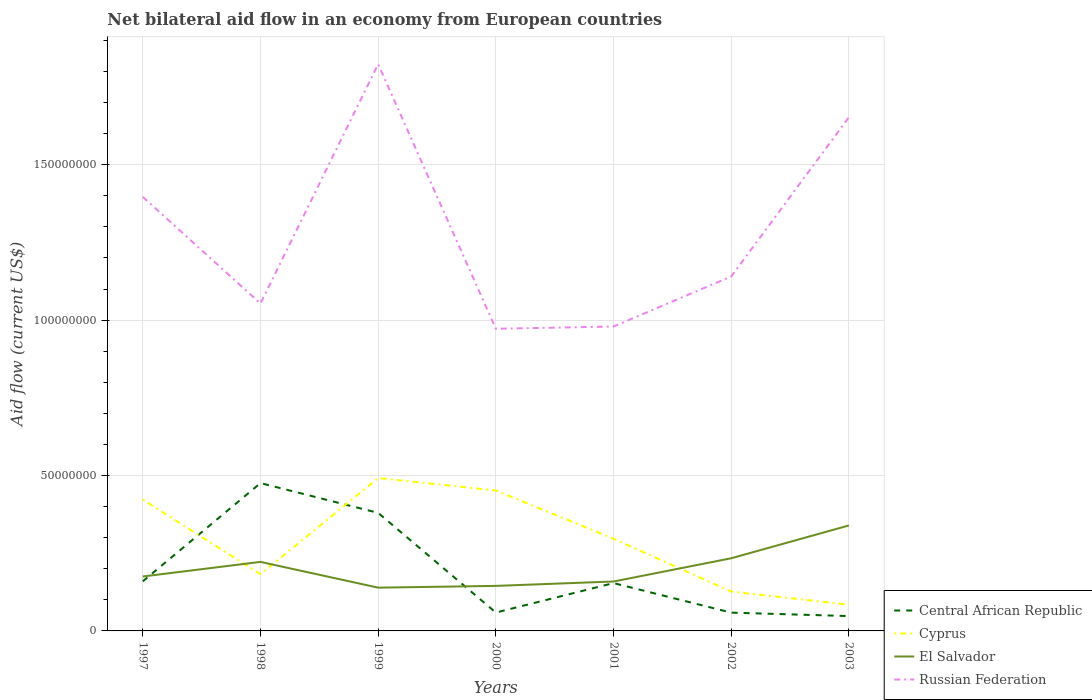Does the line corresponding to El Salvador intersect with the line corresponding to Russian Federation?
Ensure brevity in your answer.  No. Is the number of lines equal to the number of legend labels?
Your answer should be very brief. Yes. Across all years, what is the maximum net bilateral aid flow in Russian Federation?
Make the answer very short. 9.72e+07. What is the total net bilateral aid flow in Cyprus in the graph?
Provide a short and direct response. 2.96e+07. What is the difference between the highest and the second highest net bilateral aid flow in Central African Republic?
Ensure brevity in your answer.  4.28e+07. What is the difference between the highest and the lowest net bilateral aid flow in Russian Federation?
Ensure brevity in your answer.  3. How many years are there in the graph?
Your answer should be compact. 7. What is the difference between two consecutive major ticks on the Y-axis?
Provide a succinct answer. 5.00e+07. Are the values on the major ticks of Y-axis written in scientific E-notation?
Make the answer very short. No. Does the graph contain grids?
Give a very brief answer. Yes. How are the legend labels stacked?
Offer a very short reply. Vertical. What is the title of the graph?
Provide a succinct answer. Net bilateral aid flow in an economy from European countries. What is the Aid flow (current US$) of Central African Republic in 1997?
Give a very brief answer. 1.60e+07. What is the Aid flow (current US$) in Cyprus in 1997?
Provide a short and direct response. 4.23e+07. What is the Aid flow (current US$) in El Salvador in 1997?
Your answer should be very brief. 1.75e+07. What is the Aid flow (current US$) of Russian Federation in 1997?
Your answer should be very brief. 1.40e+08. What is the Aid flow (current US$) in Central African Republic in 1998?
Your answer should be very brief. 4.76e+07. What is the Aid flow (current US$) of Cyprus in 1998?
Offer a terse response. 1.82e+07. What is the Aid flow (current US$) in El Salvador in 1998?
Provide a succinct answer. 2.22e+07. What is the Aid flow (current US$) of Russian Federation in 1998?
Provide a short and direct response. 1.05e+08. What is the Aid flow (current US$) in Central African Republic in 1999?
Make the answer very short. 3.80e+07. What is the Aid flow (current US$) of Cyprus in 1999?
Your response must be concise. 4.92e+07. What is the Aid flow (current US$) in El Salvador in 1999?
Keep it short and to the point. 1.39e+07. What is the Aid flow (current US$) of Russian Federation in 1999?
Make the answer very short. 1.82e+08. What is the Aid flow (current US$) of Central African Republic in 2000?
Keep it short and to the point. 5.91e+06. What is the Aid flow (current US$) of Cyprus in 2000?
Provide a succinct answer. 4.52e+07. What is the Aid flow (current US$) of El Salvador in 2000?
Your answer should be very brief. 1.45e+07. What is the Aid flow (current US$) in Russian Federation in 2000?
Your answer should be very brief. 9.72e+07. What is the Aid flow (current US$) in Central African Republic in 2001?
Keep it short and to the point. 1.54e+07. What is the Aid flow (current US$) in Cyprus in 2001?
Provide a succinct answer. 2.97e+07. What is the Aid flow (current US$) in El Salvador in 2001?
Give a very brief answer. 1.59e+07. What is the Aid flow (current US$) in Russian Federation in 2001?
Provide a short and direct response. 9.80e+07. What is the Aid flow (current US$) of Central African Republic in 2002?
Your answer should be compact. 5.88e+06. What is the Aid flow (current US$) in Cyprus in 2002?
Your response must be concise. 1.27e+07. What is the Aid flow (current US$) of El Salvador in 2002?
Provide a short and direct response. 2.34e+07. What is the Aid flow (current US$) of Russian Federation in 2002?
Provide a short and direct response. 1.14e+08. What is the Aid flow (current US$) of Central African Republic in 2003?
Ensure brevity in your answer.  4.78e+06. What is the Aid flow (current US$) in Cyprus in 2003?
Provide a short and direct response. 8.44e+06. What is the Aid flow (current US$) of El Salvador in 2003?
Keep it short and to the point. 3.39e+07. What is the Aid flow (current US$) in Russian Federation in 2003?
Make the answer very short. 1.65e+08. Across all years, what is the maximum Aid flow (current US$) of Central African Republic?
Provide a succinct answer. 4.76e+07. Across all years, what is the maximum Aid flow (current US$) of Cyprus?
Offer a terse response. 4.92e+07. Across all years, what is the maximum Aid flow (current US$) in El Salvador?
Your answer should be compact. 3.39e+07. Across all years, what is the maximum Aid flow (current US$) of Russian Federation?
Provide a succinct answer. 1.82e+08. Across all years, what is the minimum Aid flow (current US$) in Central African Republic?
Your response must be concise. 4.78e+06. Across all years, what is the minimum Aid flow (current US$) of Cyprus?
Your answer should be very brief. 8.44e+06. Across all years, what is the minimum Aid flow (current US$) of El Salvador?
Give a very brief answer. 1.39e+07. Across all years, what is the minimum Aid flow (current US$) of Russian Federation?
Give a very brief answer. 9.72e+07. What is the total Aid flow (current US$) in Central African Republic in the graph?
Give a very brief answer. 1.33e+08. What is the total Aid flow (current US$) in Cyprus in the graph?
Offer a very short reply. 2.06e+08. What is the total Aid flow (current US$) in El Salvador in the graph?
Your answer should be very brief. 1.41e+08. What is the total Aid flow (current US$) in Russian Federation in the graph?
Your answer should be compact. 9.02e+08. What is the difference between the Aid flow (current US$) of Central African Republic in 1997 and that in 1998?
Give a very brief answer. -3.16e+07. What is the difference between the Aid flow (current US$) of Cyprus in 1997 and that in 1998?
Your response must be concise. 2.40e+07. What is the difference between the Aid flow (current US$) in El Salvador in 1997 and that in 1998?
Your response must be concise. -4.69e+06. What is the difference between the Aid flow (current US$) of Russian Federation in 1997 and that in 1998?
Your answer should be compact. 3.43e+07. What is the difference between the Aid flow (current US$) in Central African Republic in 1997 and that in 1999?
Provide a succinct answer. -2.20e+07. What is the difference between the Aid flow (current US$) in Cyprus in 1997 and that in 1999?
Make the answer very short. -6.93e+06. What is the difference between the Aid flow (current US$) of El Salvador in 1997 and that in 1999?
Make the answer very short. 3.60e+06. What is the difference between the Aid flow (current US$) in Russian Federation in 1997 and that in 1999?
Your answer should be compact. -4.27e+07. What is the difference between the Aid flow (current US$) of Central African Republic in 1997 and that in 2000?
Offer a terse response. 1.00e+07. What is the difference between the Aid flow (current US$) in Cyprus in 1997 and that in 2000?
Your response must be concise. -2.93e+06. What is the difference between the Aid flow (current US$) in El Salvador in 1997 and that in 2000?
Offer a terse response. 3.03e+06. What is the difference between the Aid flow (current US$) of Russian Federation in 1997 and that in 2000?
Your response must be concise. 4.24e+07. What is the difference between the Aid flow (current US$) in Central African Republic in 1997 and that in 2001?
Your answer should be compact. 5.70e+05. What is the difference between the Aid flow (current US$) in Cyprus in 1997 and that in 2001?
Give a very brief answer. 1.26e+07. What is the difference between the Aid flow (current US$) in El Salvador in 1997 and that in 2001?
Make the answer very short. 1.62e+06. What is the difference between the Aid flow (current US$) in Russian Federation in 1997 and that in 2001?
Ensure brevity in your answer.  4.17e+07. What is the difference between the Aid flow (current US$) in Central African Republic in 1997 and that in 2002?
Provide a succinct answer. 1.01e+07. What is the difference between the Aid flow (current US$) of Cyprus in 1997 and that in 2002?
Ensure brevity in your answer.  2.96e+07. What is the difference between the Aid flow (current US$) of El Salvador in 1997 and that in 2002?
Your answer should be compact. -5.86e+06. What is the difference between the Aid flow (current US$) of Russian Federation in 1997 and that in 2002?
Provide a short and direct response. 2.56e+07. What is the difference between the Aid flow (current US$) of Central African Republic in 1997 and that in 2003?
Offer a terse response. 1.12e+07. What is the difference between the Aid flow (current US$) in Cyprus in 1997 and that in 2003?
Ensure brevity in your answer.  3.38e+07. What is the difference between the Aid flow (current US$) of El Salvador in 1997 and that in 2003?
Ensure brevity in your answer.  -1.64e+07. What is the difference between the Aid flow (current US$) of Russian Federation in 1997 and that in 2003?
Give a very brief answer. -2.56e+07. What is the difference between the Aid flow (current US$) in Central African Republic in 1998 and that in 1999?
Provide a short and direct response. 9.59e+06. What is the difference between the Aid flow (current US$) of Cyprus in 1998 and that in 1999?
Your answer should be compact. -3.10e+07. What is the difference between the Aid flow (current US$) in El Salvador in 1998 and that in 1999?
Your answer should be compact. 8.29e+06. What is the difference between the Aid flow (current US$) in Russian Federation in 1998 and that in 1999?
Keep it short and to the point. -7.70e+07. What is the difference between the Aid flow (current US$) in Central African Republic in 1998 and that in 2000?
Provide a short and direct response. 4.17e+07. What is the difference between the Aid flow (current US$) of Cyprus in 1998 and that in 2000?
Your answer should be compact. -2.70e+07. What is the difference between the Aid flow (current US$) of El Salvador in 1998 and that in 2000?
Your answer should be very brief. 7.72e+06. What is the difference between the Aid flow (current US$) in Russian Federation in 1998 and that in 2000?
Your response must be concise. 8.12e+06. What is the difference between the Aid flow (current US$) in Central African Republic in 1998 and that in 2001?
Give a very brief answer. 3.22e+07. What is the difference between the Aid flow (current US$) in Cyprus in 1998 and that in 2001?
Your answer should be very brief. -1.14e+07. What is the difference between the Aid flow (current US$) of El Salvador in 1998 and that in 2001?
Your response must be concise. 6.31e+06. What is the difference between the Aid flow (current US$) of Russian Federation in 1998 and that in 2001?
Your answer should be compact. 7.39e+06. What is the difference between the Aid flow (current US$) in Central African Republic in 1998 and that in 2002?
Offer a very short reply. 4.17e+07. What is the difference between the Aid flow (current US$) of Cyprus in 1998 and that in 2002?
Keep it short and to the point. 5.57e+06. What is the difference between the Aid flow (current US$) in El Salvador in 1998 and that in 2002?
Make the answer very short. -1.17e+06. What is the difference between the Aid flow (current US$) in Russian Federation in 1998 and that in 2002?
Your response must be concise. -8.71e+06. What is the difference between the Aid flow (current US$) of Central African Republic in 1998 and that in 2003?
Your response must be concise. 4.28e+07. What is the difference between the Aid flow (current US$) of Cyprus in 1998 and that in 2003?
Offer a terse response. 9.79e+06. What is the difference between the Aid flow (current US$) of El Salvador in 1998 and that in 2003?
Offer a terse response. -1.17e+07. What is the difference between the Aid flow (current US$) in Russian Federation in 1998 and that in 2003?
Keep it short and to the point. -5.99e+07. What is the difference between the Aid flow (current US$) in Central African Republic in 1999 and that in 2000?
Make the answer very short. 3.21e+07. What is the difference between the Aid flow (current US$) of El Salvador in 1999 and that in 2000?
Give a very brief answer. -5.70e+05. What is the difference between the Aid flow (current US$) of Russian Federation in 1999 and that in 2000?
Offer a terse response. 8.51e+07. What is the difference between the Aid flow (current US$) in Central African Republic in 1999 and that in 2001?
Give a very brief answer. 2.26e+07. What is the difference between the Aid flow (current US$) of Cyprus in 1999 and that in 2001?
Your response must be concise. 1.95e+07. What is the difference between the Aid flow (current US$) of El Salvador in 1999 and that in 2001?
Keep it short and to the point. -1.98e+06. What is the difference between the Aid flow (current US$) in Russian Federation in 1999 and that in 2001?
Your response must be concise. 8.44e+07. What is the difference between the Aid flow (current US$) of Central African Republic in 1999 and that in 2002?
Make the answer very short. 3.21e+07. What is the difference between the Aid flow (current US$) in Cyprus in 1999 and that in 2002?
Provide a succinct answer. 3.65e+07. What is the difference between the Aid flow (current US$) of El Salvador in 1999 and that in 2002?
Keep it short and to the point. -9.46e+06. What is the difference between the Aid flow (current US$) of Russian Federation in 1999 and that in 2002?
Make the answer very short. 6.83e+07. What is the difference between the Aid flow (current US$) in Central African Republic in 1999 and that in 2003?
Keep it short and to the point. 3.32e+07. What is the difference between the Aid flow (current US$) of Cyprus in 1999 and that in 2003?
Make the answer very short. 4.08e+07. What is the difference between the Aid flow (current US$) in El Salvador in 1999 and that in 2003?
Your answer should be very brief. -2.00e+07. What is the difference between the Aid flow (current US$) in Russian Federation in 1999 and that in 2003?
Your answer should be compact. 1.71e+07. What is the difference between the Aid flow (current US$) in Central African Republic in 2000 and that in 2001?
Your answer should be very brief. -9.48e+06. What is the difference between the Aid flow (current US$) in Cyprus in 2000 and that in 2001?
Give a very brief answer. 1.55e+07. What is the difference between the Aid flow (current US$) of El Salvador in 2000 and that in 2001?
Make the answer very short. -1.41e+06. What is the difference between the Aid flow (current US$) in Russian Federation in 2000 and that in 2001?
Offer a very short reply. -7.30e+05. What is the difference between the Aid flow (current US$) in Cyprus in 2000 and that in 2002?
Offer a very short reply. 3.25e+07. What is the difference between the Aid flow (current US$) of El Salvador in 2000 and that in 2002?
Your response must be concise. -8.89e+06. What is the difference between the Aid flow (current US$) of Russian Federation in 2000 and that in 2002?
Your response must be concise. -1.68e+07. What is the difference between the Aid flow (current US$) in Central African Republic in 2000 and that in 2003?
Offer a very short reply. 1.13e+06. What is the difference between the Aid flow (current US$) of Cyprus in 2000 and that in 2003?
Make the answer very short. 3.68e+07. What is the difference between the Aid flow (current US$) in El Salvador in 2000 and that in 2003?
Offer a very short reply. -1.94e+07. What is the difference between the Aid flow (current US$) of Russian Federation in 2000 and that in 2003?
Keep it short and to the point. -6.81e+07. What is the difference between the Aid flow (current US$) of Central African Republic in 2001 and that in 2002?
Keep it short and to the point. 9.51e+06. What is the difference between the Aid flow (current US$) of Cyprus in 2001 and that in 2002?
Your response must be concise. 1.70e+07. What is the difference between the Aid flow (current US$) of El Salvador in 2001 and that in 2002?
Provide a succinct answer. -7.48e+06. What is the difference between the Aid flow (current US$) of Russian Federation in 2001 and that in 2002?
Provide a short and direct response. -1.61e+07. What is the difference between the Aid flow (current US$) in Central African Republic in 2001 and that in 2003?
Your response must be concise. 1.06e+07. What is the difference between the Aid flow (current US$) in Cyprus in 2001 and that in 2003?
Make the answer very short. 2.12e+07. What is the difference between the Aid flow (current US$) in El Salvador in 2001 and that in 2003?
Make the answer very short. -1.80e+07. What is the difference between the Aid flow (current US$) in Russian Federation in 2001 and that in 2003?
Ensure brevity in your answer.  -6.73e+07. What is the difference between the Aid flow (current US$) in Central African Republic in 2002 and that in 2003?
Your response must be concise. 1.10e+06. What is the difference between the Aid flow (current US$) of Cyprus in 2002 and that in 2003?
Offer a terse response. 4.22e+06. What is the difference between the Aid flow (current US$) of El Salvador in 2002 and that in 2003?
Your response must be concise. -1.06e+07. What is the difference between the Aid flow (current US$) in Russian Federation in 2002 and that in 2003?
Provide a succinct answer. -5.12e+07. What is the difference between the Aid flow (current US$) in Central African Republic in 1997 and the Aid flow (current US$) in Cyprus in 1998?
Your answer should be compact. -2.27e+06. What is the difference between the Aid flow (current US$) of Central African Republic in 1997 and the Aid flow (current US$) of El Salvador in 1998?
Your answer should be very brief. -6.25e+06. What is the difference between the Aid flow (current US$) in Central African Republic in 1997 and the Aid flow (current US$) in Russian Federation in 1998?
Provide a short and direct response. -8.94e+07. What is the difference between the Aid flow (current US$) in Cyprus in 1997 and the Aid flow (current US$) in El Salvador in 1998?
Your answer should be compact. 2.00e+07. What is the difference between the Aid flow (current US$) in Cyprus in 1997 and the Aid flow (current US$) in Russian Federation in 1998?
Make the answer very short. -6.31e+07. What is the difference between the Aid flow (current US$) in El Salvador in 1997 and the Aid flow (current US$) in Russian Federation in 1998?
Your answer should be very brief. -8.78e+07. What is the difference between the Aid flow (current US$) in Central African Republic in 1997 and the Aid flow (current US$) in Cyprus in 1999?
Make the answer very short. -3.32e+07. What is the difference between the Aid flow (current US$) of Central African Republic in 1997 and the Aid flow (current US$) of El Salvador in 1999?
Offer a very short reply. 2.04e+06. What is the difference between the Aid flow (current US$) in Central African Republic in 1997 and the Aid flow (current US$) in Russian Federation in 1999?
Your answer should be compact. -1.66e+08. What is the difference between the Aid flow (current US$) of Cyprus in 1997 and the Aid flow (current US$) of El Salvador in 1999?
Your answer should be very brief. 2.83e+07. What is the difference between the Aid flow (current US$) of Cyprus in 1997 and the Aid flow (current US$) of Russian Federation in 1999?
Offer a very short reply. -1.40e+08. What is the difference between the Aid flow (current US$) in El Salvador in 1997 and the Aid flow (current US$) in Russian Federation in 1999?
Provide a short and direct response. -1.65e+08. What is the difference between the Aid flow (current US$) in Central African Republic in 1997 and the Aid flow (current US$) in Cyprus in 2000?
Offer a very short reply. -2.92e+07. What is the difference between the Aid flow (current US$) of Central African Republic in 1997 and the Aid flow (current US$) of El Salvador in 2000?
Provide a short and direct response. 1.47e+06. What is the difference between the Aid flow (current US$) of Central African Republic in 1997 and the Aid flow (current US$) of Russian Federation in 2000?
Make the answer very short. -8.13e+07. What is the difference between the Aid flow (current US$) of Cyprus in 1997 and the Aid flow (current US$) of El Salvador in 2000?
Your response must be concise. 2.78e+07. What is the difference between the Aid flow (current US$) in Cyprus in 1997 and the Aid flow (current US$) in Russian Federation in 2000?
Ensure brevity in your answer.  -5.50e+07. What is the difference between the Aid flow (current US$) of El Salvador in 1997 and the Aid flow (current US$) of Russian Federation in 2000?
Give a very brief answer. -7.97e+07. What is the difference between the Aid flow (current US$) in Central African Republic in 1997 and the Aid flow (current US$) in Cyprus in 2001?
Ensure brevity in your answer.  -1.37e+07. What is the difference between the Aid flow (current US$) in Central African Republic in 1997 and the Aid flow (current US$) in El Salvador in 2001?
Ensure brevity in your answer.  6.00e+04. What is the difference between the Aid flow (current US$) of Central African Republic in 1997 and the Aid flow (current US$) of Russian Federation in 2001?
Make the answer very short. -8.20e+07. What is the difference between the Aid flow (current US$) in Cyprus in 1997 and the Aid flow (current US$) in El Salvador in 2001?
Give a very brief answer. 2.64e+07. What is the difference between the Aid flow (current US$) of Cyprus in 1997 and the Aid flow (current US$) of Russian Federation in 2001?
Provide a succinct answer. -5.57e+07. What is the difference between the Aid flow (current US$) in El Salvador in 1997 and the Aid flow (current US$) in Russian Federation in 2001?
Your answer should be compact. -8.04e+07. What is the difference between the Aid flow (current US$) of Central African Republic in 1997 and the Aid flow (current US$) of Cyprus in 2002?
Your answer should be compact. 3.30e+06. What is the difference between the Aid flow (current US$) of Central African Republic in 1997 and the Aid flow (current US$) of El Salvador in 2002?
Your answer should be compact. -7.42e+06. What is the difference between the Aid flow (current US$) in Central African Republic in 1997 and the Aid flow (current US$) in Russian Federation in 2002?
Offer a very short reply. -9.81e+07. What is the difference between the Aid flow (current US$) in Cyprus in 1997 and the Aid flow (current US$) in El Salvador in 2002?
Provide a succinct answer. 1.89e+07. What is the difference between the Aid flow (current US$) of Cyprus in 1997 and the Aid flow (current US$) of Russian Federation in 2002?
Provide a short and direct response. -7.18e+07. What is the difference between the Aid flow (current US$) in El Salvador in 1997 and the Aid flow (current US$) in Russian Federation in 2002?
Make the answer very short. -9.65e+07. What is the difference between the Aid flow (current US$) of Central African Republic in 1997 and the Aid flow (current US$) of Cyprus in 2003?
Keep it short and to the point. 7.52e+06. What is the difference between the Aid flow (current US$) in Central African Republic in 1997 and the Aid flow (current US$) in El Salvador in 2003?
Make the answer very short. -1.80e+07. What is the difference between the Aid flow (current US$) in Central African Republic in 1997 and the Aid flow (current US$) in Russian Federation in 2003?
Offer a terse response. -1.49e+08. What is the difference between the Aid flow (current US$) in Cyprus in 1997 and the Aid flow (current US$) in El Salvador in 2003?
Provide a short and direct response. 8.32e+06. What is the difference between the Aid flow (current US$) in Cyprus in 1997 and the Aid flow (current US$) in Russian Federation in 2003?
Provide a short and direct response. -1.23e+08. What is the difference between the Aid flow (current US$) of El Salvador in 1997 and the Aid flow (current US$) of Russian Federation in 2003?
Give a very brief answer. -1.48e+08. What is the difference between the Aid flow (current US$) of Central African Republic in 1998 and the Aid flow (current US$) of Cyprus in 1999?
Ensure brevity in your answer.  -1.62e+06. What is the difference between the Aid flow (current US$) in Central African Republic in 1998 and the Aid flow (current US$) in El Salvador in 1999?
Offer a terse response. 3.36e+07. What is the difference between the Aid flow (current US$) in Central African Republic in 1998 and the Aid flow (current US$) in Russian Federation in 1999?
Provide a succinct answer. -1.35e+08. What is the difference between the Aid flow (current US$) of Cyprus in 1998 and the Aid flow (current US$) of El Salvador in 1999?
Your answer should be compact. 4.31e+06. What is the difference between the Aid flow (current US$) of Cyprus in 1998 and the Aid flow (current US$) of Russian Federation in 1999?
Your response must be concise. -1.64e+08. What is the difference between the Aid flow (current US$) in El Salvador in 1998 and the Aid flow (current US$) in Russian Federation in 1999?
Your response must be concise. -1.60e+08. What is the difference between the Aid flow (current US$) in Central African Republic in 1998 and the Aid flow (current US$) in Cyprus in 2000?
Offer a terse response. 2.38e+06. What is the difference between the Aid flow (current US$) of Central African Republic in 1998 and the Aid flow (current US$) of El Salvador in 2000?
Ensure brevity in your answer.  3.31e+07. What is the difference between the Aid flow (current US$) of Central African Republic in 1998 and the Aid flow (current US$) of Russian Federation in 2000?
Your response must be concise. -4.96e+07. What is the difference between the Aid flow (current US$) of Cyprus in 1998 and the Aid flow (current US$) of El Salvador in 2000?
Your answer should be very brief. 3.74e+06. What is the difference between the Aid flow (current US$) of Cyprus in 1998 and the Aid flow (current US$) of Russian Federation in 2000?
Provide a succinct answer. -7.90e+07. What is the difference between the Aid flow (current US$) of El Salvador in 1998 and the Aid flow (current US$) of Russian Federation in 2000?
Provide a succinct answer. -7.50e+07. What is the difference between the Aid flow (current US$) in Central African Republic in 1998 and the Aid flow (current US$) in Cyprus in 2001?
Ensure brevity in your answer.  1.79e+07. What is the difference between the Aid flow (current US$) in Central African Republic in 1998 and the Aid flow (current US$) in El Salvador in 2001?
Your answer should be compact. 3.17e+07. What is the difference between the Aid flow (current US$) in Central African Republic in 1998 and the Aid flow (current US$) in Russian Federation in 2001?
Make the answer very short. -5.04e+07. What is the difference between the Aid flow (current US$) in Cyprus in 1998 and the Aid flow (current US$) in El Salvador in 2001?
Ensure brevity in your answer.  2.33e+06. What is the difference between the Aid flow (current US$) in Cyprus in 1998 and the Aid flow (current US$) in Russian Federation in 2001?
Your response must be concise. -7.97e+07. What is the difference between the Aid flow (current US$) in El Salvador in 1998 and the Aid flow (current US$) in Russian Federation in 2001?
Your response must be concise. -7.57e+07. What is the difference between the Aid flow (current US$) of Central African Republic in 1998 and the Aid flow (current US$) of Cyprus in 2002?
Your response must be concise. 3.49e+07. What is the difference between the Aid flow (current US$) of Central African Republic in 1998 and the Aid flow (current US$) of El Salvador in 2002?
Keep it short and to the point. 2.42e+07. What is the difference between the Aid flow (current US$) in Central African Republic in 1998 and the Aid flow (current US$) in Russian Federation in 2002?
Keep it short and to the point. -6.65e+07. What is the difference between the Aid flow (current US$) in Cyprus in 1998 and the Aid flow (current US$) in El Salvador in 2002?
Give a very brief answer. -5.15e+06. What is the difference between the Aid flow (current US$) in Cyprus in 1998 and the Aid flow (current US$) in Russian Federation in 2002?
Provide a short and direct response. -9.58e+07. What is the difference between the Aid flow (current US$) of El Salvador in 1998 and the Aid flow (current US$) of Russian Federation in 2002?
Provide a short and direct response. -9.18e+07. What is the difference between the Aid flow (current US$) in Central African Republic in 1998 and the Aid flow (current US$) in Cyprus in 2003?
Your response must be concise. 3.91e+07. What is the difference between the Aid flow (current US$) in Central African Republic in 1998 and the Aid flow (current US$) in El Salvador in 2003?
Ensure brevity in your answer.  1.36e+07. What is the difference between the Aid flow (current US$) in Central African Republic in 1998 and the Aid flow (current US$) in Russian Federation in 2003?
Give a very brief answer. -1.18e+08. What is the difference between the Aid flow (current US$) of Cyprus in 1998 and the Aid flow (current US$) of El Salvador in 2003?
Offer a very short reply. -1.57e+07. What is the difference between the Aid flow (current US$) of Cyprus in 1998 and the Aid flow (current US$) of Russian Federation in 2003?
Your answer should be compact. -1.47e+08. What is the difference between the Aid flow (current US$) in El Salvador in 1998 and the Aid flow (current US$) in Russian Federation in 2003?
Your answer should be very brief. -1.43e+08. What is the difference between the Aid flow (current US$) in Central African Republic in 1999 and the Aid flow (current US$) in Cyprus in 2000?
Make the answer very short. -7.21e+06. What is the difference between the Aid flow (current US$) of Central African Republic in 1999 and the Aid flow (current US$) of El Salvador in 2000?
Provide a succinct answer. 2.35e+07. What is the difference between the Aid flow (current US$) in Central African Republic in 1999 and the Aid flow (current US$) in Russian Federation in 2000?
Ensure brevity in your answer.  -5.92e+07. What is the difference between the Aid flow (current US$) of Cyprus in 1999 and the Aid flow (current US$) of El Salvador in 2000?
Offer a very short reply. 3.47e+07. What is the difference between the Aid flow (current US$) of Cyprus in 1999 and the Aid flow (current US$) of Russian Federation in 2000?
Provide a succinct answer. -4.80e+07. What is the difference between the Aid flow (current US$) of El Salvador in 1999 and the Aid flow (current US$) of Russian Federation in 2000?
Provide a succinct answer. -8.33e+07. What is the difference between the Aid flow (current US$) of Central African Republic in 1999 and the Aid flow (current US$) of Cyprus in 2001?
Keep it short and to the point. 8.32e+06. What is the difference between the Aid flow (current US$) in Central African Republic in 1999 and the Aid flow (current US$) in El Salvador in 2001?
Provide a succinct answer. 2.21e+07. What is the difference between the Aid flow (current US$) in Central African Republic in 1999 and the Aid flow (current US$) in Russian Federation in 2001?
Provide a succinct answer. -6.00e+07. What is the difference between the Aid flow (current US$) in Cyprus in 1999 and the Aid flow (current US$) in El Salvador in 2001?
Your answer should be very brief. 3.33e+07. What is the difference between the Aid flow (current US$) in Cyprus in 1999 and the Aid flow (current US$) in Russian Federation in 2001?
Your response must be concise. -4.88e+07. What is the difference between the Aid flow (current US$) in El Salvador in 1999 and the Aid flow (current US$) in Russian Federation in 2001?
Your answer should be compact. -8.40e+07. What is the difference between the Aid flow (current US$) in Central African Republic in 1999 and the Aid flow (current US$) in Cyprus in 2002?
Ensure brevity in your answer.  2.53e+07. What is the difference between the Aid flow (current US$) in Central African Republic in 1999 and the Aid flow (current US$) in El Salvador in 2002?
Keep it short and to the point. 1.46e+07. What is the difference between the Aid flow (current US$) in Central African Republic in 1999 and the Aid flow (current US$) in Russian Federation in 2002?
Provide a succinct answer. -7.61e+07. What is the difference between the Aid flow (current US$) in Cyprus in 1999 and the Aid flow (current US$) in El Salvador in 2002?
Your answer should be compact. 2.58e+07. What is the difference between the Aid flow (current US$) in Cyprus in 1999 and the Aid flow (current US$) in Russian Federation in 2002?
Ensure brevity in your answer.  -6.49e+07. What is the difference between the Aid flow (current US$) in El Salvador in 1999 and the Aid flow (current US$) in Russian Federation in 2002?
Provide a short and direct response. -1.00e+08. What is the difference between the Aid flow (current US$) of Central African Republic in 1999 and the Aid flow (current US$) of Cyprus in 2003?
Keep it short and to the point. 2.95e+07. What is the difference between the Aid flow (current US$) in Central African Republic in 1999 and the Aid flow (current US$) in El Salvador in 2003?
Offer a terse response. 4.04e+06. What is the difference between the Aid flow (current US$) of Central African Republic in 1999 and the Aid flow (current US$) of Russian Federation in 2003?
Offer a very short reply. -1.27e+08. What is the difference between the Aid flow (current US$) in Cyprus in 1999 and the Aid flow (current US$) in El Salvador in 2003?
Your response must be concise. 1.52e+07. What is the difference between the Aid flow (current US$) in Cyprus in 1999 and the Aid flow (current US$) in Russian Federation in 2003?
Provide a short and direct response. -1.16e+08. What is the difference between the Aid flow (current US$) of El Salvador in 1999 and the Aid flow (current US$) of Russian Federation in 2003?
Ensure brevity in your answer.  -1.51e+08. What is the difference between the Aid flow (current US$) in Central African Republic in 2000 and the Aid flow (current US$) in Cyprus in 2001?
Provide a succinct answer. -2.38e+07. What is the difference between the Aid flow (current US$) of Central African Republic in 2000 and the Aid flow (current US$) of El Salvador in 2001?
Give a very brief answer. -9.99e+06. What is the difference between the Aid flow (current US$) of Central African Republic in 2000 and the Aid flow (current US$) of Russian Federation in 2001?
Provide a succinct answer. -9.20e+07. What is the difference between the Aid flow (current US$) in Cyprus in 2000 and the Aid flow (current US$) in El Salvador in 2001?
Provide a succinct answer. 2.93e+07. What is the difference between the Aid flow (current US$) in Cyprus in 2000 and the Aid flow (current US$) in Russian Federation in 2001?
Your answer should be compact. -5.28e+07. What is the difference between the Aid flow (current US$) of El Salvador in 2000 and the Aid flow (current US$) of Russian Federation in 2001?
Ensure brevity in your answer.  -8.35e+07. What is the difference between the Aid flow (current US$) in Central African Republic in 2000 and the Aid flow (current US$) in Cyprus in 2002?
Keep it short and to the point. -6.75e+06. What is the difference between the Aid flow (current US$) in Central African Republic in 2000 and the Aid flow (current US$) in El Salvador in 2002?
Ensure brevity in your answer.  -1.75e+07. What is the difference between the Aid flow (current US$) in Central African Republic in 2000 and the Aid flow (current US$) in Russian Federation in 2002?
Your answer should be compact. -1.08e+08. What is the difference between the Aid flow (current US$) in Cyprus in 2000 and the Aid flow (current US$) in El Salvador in 2002?
Your answer should be compact. 2.18e+07. What is the difference between the Aid flow (current US$) of Cyprus in 2000 and the Aid flow (current US$) of Russian Federation in 2002?
Your response must be concise. -6.89e+07. What is the difference between the Aid flow (current US$) of El Salvador in 2000 and the Aid flow (current US$) of Russian Federation in 2002?
Offer a very short reply. -9.96e+07. What is the difference between the Aid flow (current US$) in Central African Republic in 2000 and the Aid flow (current US$) in Cyprus in 2003?
Make the answer very short. -2.53e+06. What is the difference between the Aid flow (current US$) of Central African Republic in 2000 and the Aid flow (current US$) of El Salvador in 2003?
Give a very brief answer. -2.80e+07. What is the difference between the Aid flow (current US$) of Central African Republic in 2000 and the Aid flow (current US$) of Russian Federation in 2003?
Offer a terse response. -1.59e+08. What is the difference between the Aid flow (current US$) of Cyprus in 2000 and the Aid flow (current US$) of El Salvador in 2003?
Your response must be concise. 1.12e+07. What is the difference between the Aid flow (current US$) in Cyprus in 2000 and the Aid flow (current US$) in Russian Federation in 2003?
Your response must be concise. -1.20e+08. What is the difference between the Aid flow (current US$) in El Salvador in 2000 and the Aid flow (current US$) in Russian Federation in 2003?
Your answer should be very brief. -1.51e+08. What is the difference between the Aid flow (current US$) of Central African Republic in 2001 and the Aid flow (current US$) of Cyprus in 2002?
Keep it short and to the point. 2.73e+06. What is the difference between the Aid flow (current US$) in Central African Republic in 2001 and the Aid flow (current US$) in El Salvador in 2002?
Provide a short and direct response. -7.99e+06. What is the difference between the Aid flow (current US$) of Central African Republic in 2001 and the Aid flow (current US$) of Russian Federation in 2002?
Provide a succinct answer. -9.87e+07. What is the difference between the Aid flow (current US$) of Cyprus in 2001 and the Aid flow (current US$) of El Salvador in 2002?
Your answer should be very brief. 6.28e+06. What is the difference between the Aid flow (current US$) of Cyprus in 2001 and the Aid flow (current US$) of Russian Federation in 2002?
Ensure brevity in your answer.  -8.44e+07. What is the difference between the Aid flow (current US$) of El Salvador in 2001 and the Aid flow (current US$) of Russian Federation in 2002?
Give a very brief answer. -9.82e+07. What is the difference between the Aid flow (current US$) in Central African Republic in 2001 and the Aid flow (current US$) in Cyprus in 2003?
Ensure brevity in your answer.  6.95e+06. What is the difference between the Aid flow (current US$) in Central African Republic in 2001 and the Aid flow (current US$) in El Salvador in 2003?
Make the answer very short. -1.86e+07. What is the difference between the Aid flow (current US$) in Central African Republic in 2001 and the Aid flow (current US$) in Russian Federation in 2003?
Provide a succinct answer. -1.50e+08. What is the difference between the Aid flow (current US$) of Cyprus in 2001 and the Aid flow (current US$) of El Salvador in 2003?
Provide a succinct answer. -4.28e+06. What is the difference between the Aid flow (current US$) in Cyprus in 2001 and the Aid flow (current US$) in Russian Federation in 2003?
Provide a short and direct response. -1.36e+08. What is the difference between the Aid flow (current US$) in El Salvador in 2001 and the Aid flow (current US$) in Russian Federation in 2003?
Offer a very short reply. -1.49e+08. What is the difference between the Aid flow (current US$) in Central African Republic in 2002 and the Aid flow (current US$) in Cyprus in 2003?
Your answer should be very brief. -2.56e+06. What is the difference between the Aid flow (current US$) in Central African Republic in 2002 and the Aid flow (current US$) in El Salvador in 2003?
Provide a short and direct response. -2.81e+07. What is the difference between the Aid flow (current US$) of Central African Republic in 2002 and the Aid flow (current US$) of Russian Federation in 2003?
Your answer should be very brief. -1.59e+08. What is the difference between the Aid flow (current US$) in Cyprus in 2002 and the Aid flow (current US$) in El Salvador in 2003?
Keep it short and to the point. -2.13e+07. What is the difference between the Aid flow (current US$) of Cyprus in 2002 and the Aid flow (current US$) of Russian Federation in 2003?
Keep it short and to the point. -1.53e+08. What is the difference between the Aid flow (current US$) in El Salvador in 2002 and the Aid flow (current US$) in Russian Federation in 2003?
Your answer should be compact. -1.42e+08. What is the average Aid flow (current US$) of Central African Republic per year?
Keep it short and to the point. 1.91e+07. What is the average Aid flow (current US$) in Cyprus per year?
Keep it short and to the point. 2.94e+07. What is the average Aid flow (current US$) in El Salvador per year?
Offer a terse response. 2.02e+07. What is the average Aid flow (current US$) of Russian Federation per year?
Provide a short and direct response. 1.29e+08. In the year 1997, what is the difference between the Aid flow (current US$) in Central African Republic and Aid flow (current US$) in Cyprus?
Provide a short and direct response. -2.63e+07. In the year 1997, what is the difference between the Aid flow (current US$) of Central African Republic and Aid flow (current US$) of El Salvador?
Make the answer very short. -1.56e+06. In the year 1997, what is the difference between the Aid flow (current US$) in Central African Republic and Aid flow (current US$) in Russian Federation?
Keep it short and to the point. -1.24e+08. In the year 1997, what is the difference between the Aid flow (current US$) in Cyprus and Aid flow (current US$) in El Salvador?
Provide a short and direct response. 2.47e+07. In the year 1997, what is the difference between the Aid flow (current US$) in Cyprus and Aid flow (current US$) in Russian Federation?
Your answer should be compact. -9.74e+07. In the year 1997, what is the difference between the Aid flow (current US$) of El Salvador and Aid flow (current US$) of Russian Federation?
Offer a very short reply. -1.22e+08. In the year 1998, what is the difference between the Aid flow (current US$) of Central African Republic and Aid flow (current US$) of Cyprus?
Keep it short and to the point. 2.93e+07. In the year 1998, what is the difference between the Aid flow (current US$) in Central African Republic and Aid flow (current US$) in El Salvador?
Keep it short and to the point. 2.54e+07. In the year 1998, what is the difference between the Aid flow (current US$) in Central African Republic and Aid flow (current US$) in Russian Federation?
Keep it short and to the point. -5.78e+07. In the year 1998, what is the difference between the Aid flow (current US$) in Cyprus and Aid flow (current US$) in El Salvador?
Give a very brief answer. -3.98e+06. In the year 1998, what is the difference between the Aid flow (current US$) of Cyprus and Aid flow (current US$) of Russian Federation?
Your answer should be very brief. -8.71e+07. In the year 1998, what is the difference between the Aid flow (current US$) in El Salvador and Aid flow (current US$) in Russian Federation?
Provide a succinct answer. -8.31e+07. In the year 1999, what is the difference between the Aid flow (current US$) of Central African Republic and Aid flow (current US$) of Cyprus?
Offer a terse response. -1.12e+07. In the year 1999, what is the difference between the Aid flow (current US$) in Central African Republic and Aid flow (current US$) in El Salvador?
Your answer should be compact. 2.41e+07. In the year 1999, what is the difference between the Aid flow (current US$) in Central African Republic and Aid flow (current US$) in Russian Federation?
Your answer should be very brief. -1.44e+08. In the year 1999, what is the difference between the Aid flow (current US$) in Cyprus and Aid flow (current US$) in El Salvador?
Offer a terse response. 3.53e+07. In the year 1999, what is the difference between the Aid flow (current US$) in Cyprus and Aid flow (current US$) in Russian Federation?
Your answer should be very brief. -1.33e+08. In the year 1999, what is the difference between the Aid flow (current US$) in El Salvador and Aid flow (current US$) in Russian Federation?
Your answer should be compact. -1.68e+08. In the year 2000, what is the difference between the Aid flow (current US$) of Central African Republic and Aid flow (current US$) of Cyprus?
Ensure brevity in your answer.  -3.93e+07. In the year 2000, what is the difference between the Aid flow (current US$) in Central African Republic and Aid flow (current US$) in El Salvador?
Offer a very short reply. -8.58e+06. In the year 2000, what is the difference between the Aid flow (current US$) of Central African Republic and Aid flow (current US$) of Russian Federation?
Ensure brevity in your answer.  -9.13e+07. In the year 2000, what is the difference between the Aid flow (current US$) of Cyprus and Aid flow (current US$) of El Salvador?
Make the answer very short. 3.07e+07. In the year 2000, what is the difference between the Aid flow (current US$) in Cyprus and Aid flow (current US$) in Russian Federation?
Provide a succinct answer. -5.20e+07. In the year 2000, what is the difference between the Aid flow (current US$) of El Salvador and Aid flow (current US$) of Russian Federation?
Your answer should be very brief. -8.27e+07. In the year 2001, what is the difference between the Aid flow (current US$) in Central African Republic and Aid flow (current US$) in Cyprus?
Your answer should be very brief. -1.43e+07. In the year 2001, what is the difference between the Aid flow (current US$) of Central African Republic and Aid flow (current US$) of El Salvador?
Offer a very short reply. -5.10e+05. In the year 2001, what is the difference between the Aid flow (current US$) in Central African Republic and Aid flow (current US$) in Russian Federation?
Your response must be concise. -8.26e+07. In the year 2001, what is the difference between the Aid flow (current US$) in Cyprus and Aid flow (current US$) in El Salvador?
Offer a terse response. 1.38e+07. In the year 2001, what is the difference between the Aid flow (current US$) in Cyprus and Aid flow (current US$) in Russian Federation?
Your answer should be compact. -6.83e+07. In the year 2001, what is the difference between the Aid flow (current US$) in El Salvador and Aid flow (current US$) in Russian Federation?
Offer a very short reply. -8.20e+07. In the year 2002, what is the difference between the Aid flow (current US$) of Central African Republic and Aid flow (current US$) of Cyprus?
Provide a succinct answer. -6.78e+06. In the year 2002, what is the difference between the Aid flow (current US$) of Central African Republic and Aid flow (current US$) of El Salvador?
Make the answer very short. -1.75e+07. In the year 2002, what is the difference between the Aid flow (current US$) in Central African Republic and Aid flow (current US$) in Russian Federation?
Your answer should be compact. -1.08e+08. In the year 2002, what is the difference between the Aid flow (current US$) in Cyprus and Aid flow (current US$) in El Salvador?
Offer a very short reply. -1.07e+07. In the year 2002, what is the difference between the Aid flow (current US$) in Cyprus and Aid flow (current US$) in Russian Federation?
Keep it short and to the point. -1.01e+08. In the year 2002, what is the difference between the Aid flow (current US$) of El Salvador and Aid flow (current US$) of Russian Federation?
Your response must be concise. -9.07e+07. In the year 2003, what is the difference between the Aid flow (current US$) of Central African Republic and Aid flow (current US$) of Cyprus?
Keep it short and to the point. -3.66e+06. In the year 2003, what is the difference between the Aid flow (current US$) of Central African Republic and Aid flow (current US$) of El Salvador?
Offer a very short reply. -2.92e+07. In the year 2003, what is the difference between the Aid flow (current US$) of Central African Republic and Aid flow (current US$) of Russian Federation?
Keep it short and to the point. -1.60e+08. In the year 2003, what is the difference between the Aid flow (current US$) of Cyprus and Aid flow (current US$) of El Salvador?
Your response must be concise. -2.55e+07. In the year 2003, what is the difference between the Aid flow (current US$) of Cyprus and Aid flow (current US$) of Russian Federation?
Offer a terse response. -1.57e+08. In the year 2003, what is the difference between the Aid flow (current US$) in El Salvador and Aid flow (current US$) in Russian Federation?
Your response must be concise. -1.31e+08. What is the ratio of the Aid flow (current US$) in Central African Republic in 1997 to that in 1998?
Ensure brevity in your answer.  0.34. What is the ratio of the Aid flow (current US$) of Cyprus in 1997 to that in 1998?
Your response must be concise. 2.32. What is the ratio of the Aid flow (current US$) in El Salvador in 1997 to that in 1998?
Your answer should be compact. 0.79. What is the ratio of the Aid flow (current US$) of Russian Federation in 1997 to that in 1998?
Your answer should be very brief. 1.33. What is the ratio of the Aid flow (current US$) of Central African Republic in 1997 to that in 1999?
Offer a very short reply. 0.42. What is the ratio of the Aid flow (current US$) in Cyprus in 1997 to that in 1999?
Ensure brevity in your answer.  0.86. What is the ratio of the Aid flow (current US$) in El Salvador in 1997 to that in 1999?
Offer a terse response. 1.26. What is the ratio of the Aid flow (current US$) of Russian Federation in 1997 to that in 1999?
Offer a terse response. 0.77. What is the ratio of the Aid flow (current US$) in Central African Republic in 1997 to that in 2000?
Offer a terse response. 2.7. What is the ratio of the Aid flow (current US$) of Cyprus in 1997 to that in 2000?
Give a very brief answer. 0.94. What is the ratio of the Aid flow (current US$) of El Salvador in 1997 to that in 2000?
Give a very brief answer. 1.21. What is the ratio of the Aid flow (current US$) in Russian Federation in 1997 to that in 2000?
Give a very brief answer. 1.44. What is the ratio of the Aid flow (current US$) in Central African Republic in 1997 to that in 2001?
Offer a very short reply. 1.04. What is the ratio of the Aid flow (current US$) in Cyprus in 1997 to that in 2001?
Offer a very short reply. 1.42. What is the ratio of the Aid flow (current US$) in El Salvador in 1997 to that in 2001?
Ensure brevity in your answer.  1.1. What is the ratio of the Aid flow (current US$) in Russian Federation in 1997 to that in 2001?
Offer a terse response. 1.43. What is the ratio of the Aid flow (current US$) in Central African Republic in 1997 to that in 2002?
Offer a terse response. 2.71. What is the ratio of the Aid flow (current US$) in Cyprus in 1997 to that in 2002?
Provide a succinct answer. 3.34. What is the ratio of the Aid flow (current US$) of El Salvador in 1997 to that in 2002?
Provide a short and direct response. 0.75. What is the ratio of the Aid flow (current US$) in Russian Federation in 1997 to that in 2002?
Your answer should be very brief. 1.22. What is the ratio of the Aid flow (current US$) in Central African Republic in 1997 to that in 2003?
Keep it short and to the point. 3.34. What is the ratio of the Aid flow (current US$) of Cyprus in 1997 to that in 2003?
Offer a terse response. 5.01. What is the ratio of the Aid flow (current US$) of El Salvador in 1997 to that in 2003?
Your response must be concise. 0.52. What is the ratio of the Aid flow (current US$) in Russian Federation in 1997 to that in 2003?
Provide a succinct answer. 0.84. What is the ratio of the Aid flow (current US$) of Central African Republic in 1998 to that in 1999?
Provide a succinct answer. 1.25. What is the ratio of the Aid flow (current US$) of Cyprus in 1998 to that in 1999?
Make the answer very short. 0.37. What is the ratio of the Aid flow (current US$) of El Salvador in 1998 to that in 1999?
Offer a terse response. 1.6. What is the ratio of the Aid flow (current US$) of Russian Federation in 1998 to that in 1999?
Provide a short and direct response. 0.58. What is the ratio of the Aid flow (current US$) of Central African Republic in 1998 to that in 2000?
Offer a terse response. 8.05. What is the ratio of the Aid flow (current US$) of Cyprus in 1998 to that in 2000?
Your answer should be very brief. 0.4. What is the ratio of the Aid flow (current US$) of El Salvador in 1998 to that in 2000?
Your answer should be very brief. 1.53. What is the ratio of the Aid flow (current US$) of Russian Federation in 1998 to that in 2000?
Keep it short and to the point. 1.08. What is the ratio of the Aid flow (current US$) in Central African Republic in 1998 to that in 2001?
Offer a terse response. 3.09. What is the ratio of the Aid flow (current US$) of Cyprus in 1998 to that in 2001?
Ensure brevity in your answer.  0.61. What is the ratio of the Aid flow (current US$) of El Salvador in 1998 to that in 2001?
Your response must be concise. 1.4. What is the ratio of the Aid flow (current US$) of Russian Federation in 1998 to that in 2001?
Offer a very short reply. 1.08. What is the ratio of the Aid flow (current US$) of Central African Republic in 1998 to that in 2002?
Provide a succinct answer. 8.09. What is the ratio of the Aid flow (current US$) in Cyprus in 1998 to that in 2002?
Your answer should be compact. 1.44. What is the ratio of the Aid flow (current US$) in Russian Federation in 1998 to that in 2002?
Ensure brevity in your answer.  0.92. What is the ratio of the Aid flow (current US$) of Central African Republic in 1998 to that in 2003?
Give a very brief answer. 9.95. What is the ratio of the Aid flow (current US$) in Cyprus in 1998 to that in 2003?
Your answer should be very brief. 2.16. What is the ratio of the Aid flow (current US$) of El Salvador in 1998 to that in 2003?
Keep it short and to the point. 0.65. What is the ratio of the Aid flow (current US$) in Russian Federation in 1998 to that in 2003?
Keep it short and to the point. 0.64. What is the ratio of the Aid flow (current US$) of Central African Republic in 1999 to that in 2000?
Offer a terse response. 6.43. What is the ratio of the Aid flow (current US$) of Cyprus in 1999 to that in 2000?
Provide a succinct answer. 1.09. What is the ratio of the Aid flow (current US$) in El Salvador in 1999 to that in 2000?
Offer a very short reply. 0.96. What is the ratio of the Aid flow (current US$) in Russian Federation in 1999 to that in 2000?
Offer a very short reply. 1.88. What is the ratio of the Aid flow (current US$) in Central African Republic in 1999 to that in 2001?
Make the answer very short. 2.47. What is the ratio of the Aid flow (current US$) in Cyprus in 1999 to that in 2001?
Make the answer very short. 1.66. What is the ratio of the Aid flow (current US$) in El Salvador in 1999 to that in 2001?
Keep it short and to the point. 0.88. What is the ratio of the Aid flow (current US$) of Russian Federation in 1999 to that in 2001?
Offer a very short reply. 1.86. What is the ratio of the Aid flow (current US$) in Central African Republic in 1999 to that in 2002?
Make the answer very short. 6.46. What is the ratio of the Aid flow (current US$) in Cyprus in 1999 to that in 2002?
Offer a terse response. 3.89. What is the ratio of the Aid flow (current US$) in El Salvador in 1999 to that in 2002?
Keep it short and to the point. 0.6. What is the ratio of the Aid flow (current US$) of Russian Federation in 1999 to that in 2002?
Your answer should be compact. 1.6. What is the ratio of the Aid flow (current US$) of Central African Republic in 1999 to that in 2003?
Make the answer very short. 7.95. What is the ratio of the Aid flow (current US$) in Cyprus in 1999 to that in 2003?
Provide a succinct answer. 5.83. What is the ratio of the Aid flow (current US$) of El Salvador in 1999 to that in 2003?
Offer a very short reply. 0.41. What is the ratio of the Aid flow (current US$) of Russian Federation in 1999 to that in 2003?
Your answer should be compact. 1.1. What is the ratio of the Aid flow (current US$) of Central African Republic in 2000 to that in 2001?
Offer a terse response. 0.38. What is the ratio of the Aid flow (current US$) in Cyprus in 2000 to that in 2001?
Keep it short and to the point. 1.52. What is the ratio of the Aid flow (current US$) of El Salvador in 2000 to that in 2001?
Provide a succinct answer. 0.91. What is the ratio of the Aid flow (current US$) in Russian Federation in 2000 to that in 2001?
Your answer should be very brief. 0.99. What is the ratio of the Aid flow (current US$) of Cyprus in 2000 to that in 2002?
Keep it short and to the point. 3.57. What is the ratio of the Aid flow (current US$) of El Salvador in 2000 to that in 2002?
Your response must be concise. 0.62. What is the ratio of the Aid flow (current US$) of Russian Federation in 2000 to that in 2002?
Ensure brevity in your answer.  0.85. What is the ratio of the Aid flow (current US$) in Central African Republic in 2000 to that in 2003?
Keep it short and to the point. 1.24. What is the ratio of the Aid flow (current US$) in Cyprus in 2000 to that in 2003?
Provide a succinct answer. 5.35. What is the ratio of the Aid flow (current US$) in El Salvador in 2000 to that in 2003?
Ensure brevity in your answer.  0.43. What is the ratio of the Aid flow (current US$) of Russian Federation in 2000 to that in 2003?
Your answer should be very brief. 0.59. What is the ratio of the Aid flow (current US$) of Central African Republic in 2001 to that in 2002?
Make the answer very short. 2.62. What is the ratio of the Aid flow (current US$) in Cyprus in 2001 to that in 2002?
Offer a terse response. 2.34. What is the ratio of the Aid flow (current US$) of El Salvador in 2001 to that in 2002?
Provide a short and direct response. 0.68. What is the ratio of the Aid flow (current US$) in Russian Federation in 2001 to that in 2002?
Your response must be concise. 0.86. What is the ratio of the Aid flow (current US$) of Central African Republic in 2001 to that in 2003?
Give a very brief answer. 3.22. What is the ratio of the Aid flow (current US$) in Cyprus in 2001 to that in 2003?
Make the answer very short. 3.51. What is the ratio of the Aid flow (current US$) of El Salvador in 2001 to that in 2003?
Give a very brief answer. 0.47. What is the ratio of the Aid flow (current US$) in Russian Federation in 2001 to that in 2003?
Your response must be concise. 0.59. What is the ratio of the Aid flow (current US$) in Central African Republic in 2002 to that in 2003?
Offer a very short reply. 1.23. What is the ratio of the Aid flow (current US$) in Cyprus in 2002 to that in 2003?
Give a very brief answer. 1.5. What is the ratio of the Aid flow (current US$) of El Salvador in 2002 to that in 2003?
Make the answer very short. 0.69. What is the ratio of the Aid flow (current US$) of Russian Federation in 2002 to that in 2003?
Provide a succinct answer. 0.69. What is the difference between the highest and the second highest Aid flow (current US$) in Central African Republic?
Give a very brief answer. 9.59e+06. What is the difference between the highest and the second highest Aid flow (current US$) in El Salvador?
Offer a very short reply. 1.06e+07. What is the difference between the highest and the second highest Aid flow (current US$) in Russian Federation?
Give a very brief answer. 1.71e+07. What is the difference between the highest and the lowest Aid flow (current US$) of Central African Republic?
Ensure brevity in your answer.  4.28e+07. What is the difference between the highest and the lowest Aid flow (current US$) in Cyprus?
Your answer should be very brief. 4.08e+07. What is the difference between the highest and the lowest Aid flow (current US$) in El Salvador?
Give a very brief answer. 2.00e+07. What is the difference between the highest and the lowest Aid flow (current US$) of Russian Federation?
Give a very brief answer. 8.51e+07. 